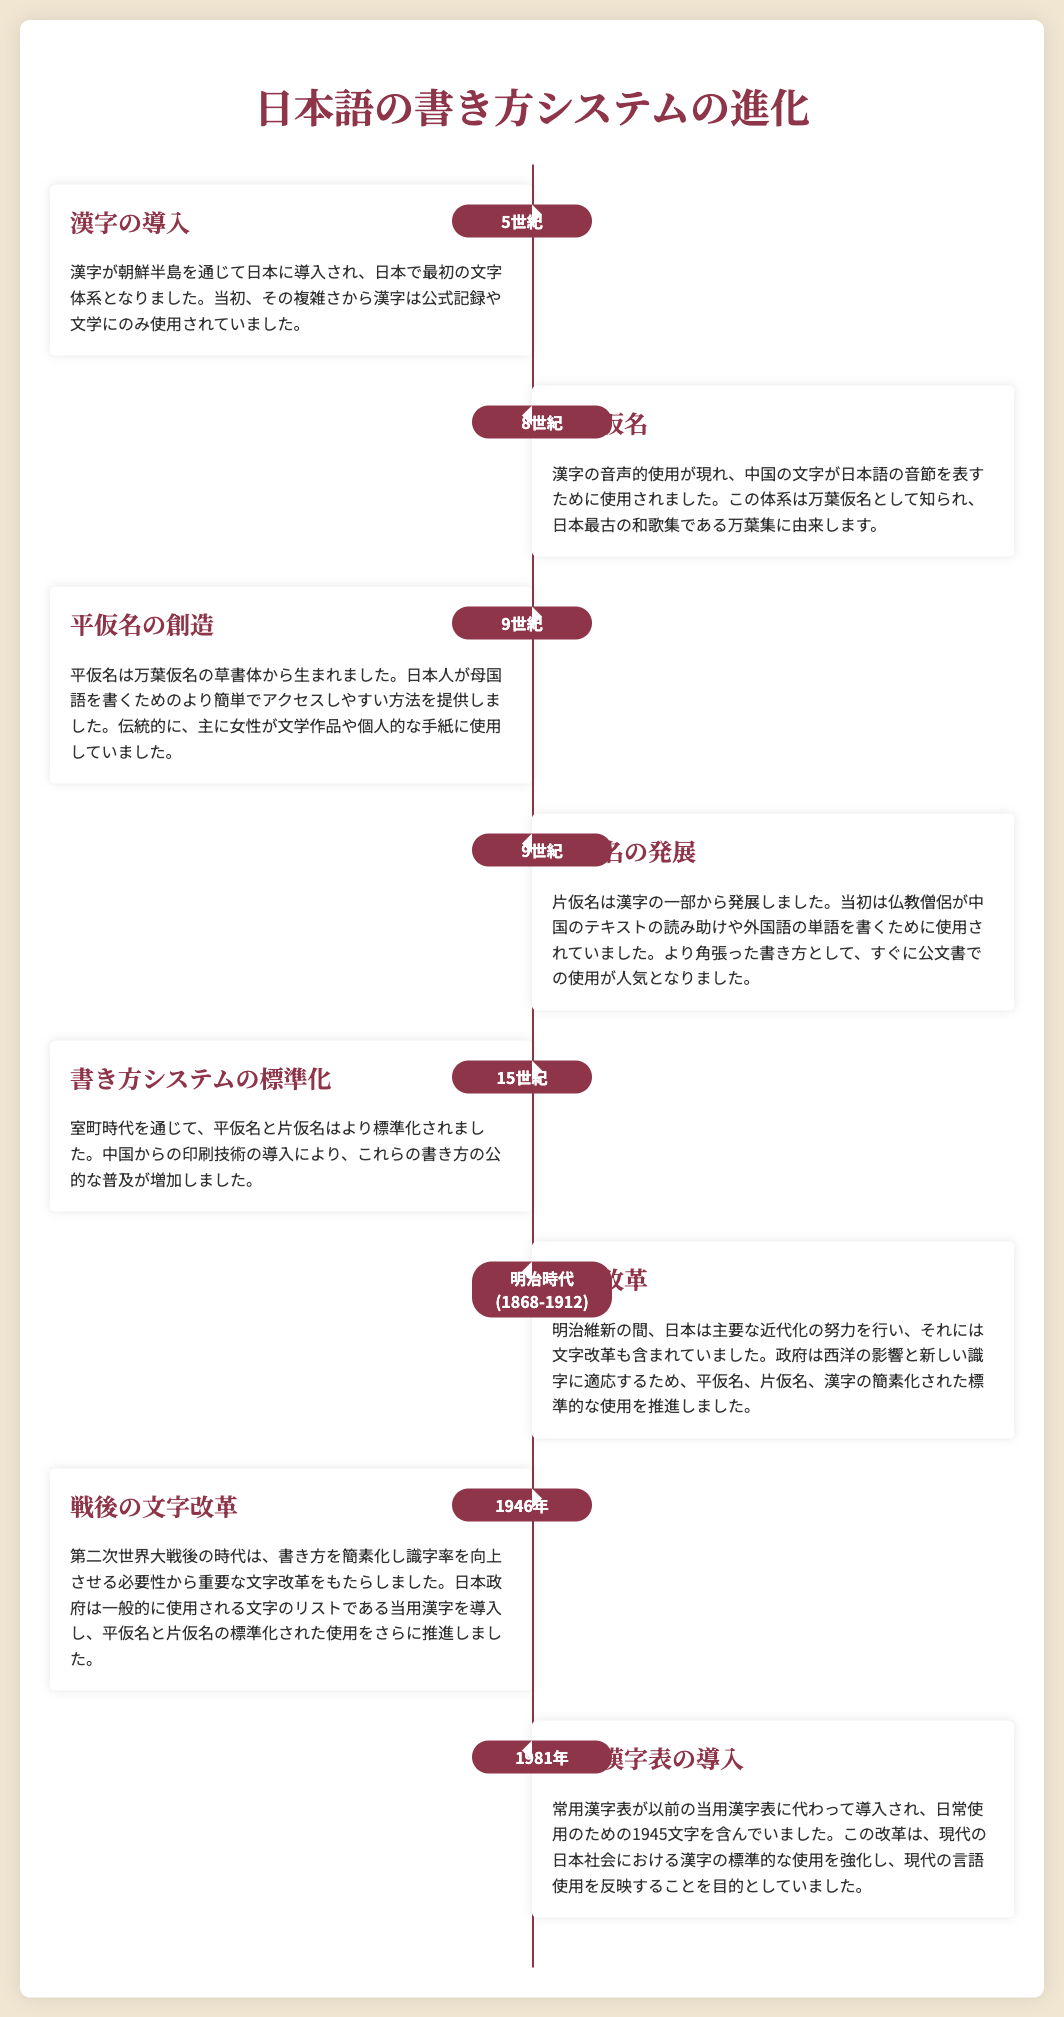what year was kanji introduced? The document states that kanji was introduced in the 5th century.
Answer: 5世紀 what is the name of the first writing system in Japan? The first writing system introduced to Japan was kanji.
Answer: 漢字 which writing system did women traditionally use for literature? The document mentions that hiragana was primarily used by women for literary works.
Answer: 平仮名 what significant reform happened during the Meiji period? During the Meiji period, language reform efforts were made to standardize the use of hiragana, katakana, and kanji.
Answer: 言語改革 what was the purpose of the commonly used kanji list introduced in 1946? The purpose of the list was to simplify writing and improve literacy rates.
Answer: 書き方を簡素化し識字率を向上させる what century saw the creation of hiragana? The document indicates that hiragana was created in the 9th century.
Answer: 9世紀 how many characters are included in the jōyō kanji table established in 1981? The document states that the jōyō kanji table includes 1945 characters for everyday use.
Answer: 1945文字 what writing system developed from part of kanji? The document clarifies that katakana developed from parts of kanji.
Answer: 片仮名 what technological influence contributed to the standardization of writing systems in the 15th century? The document mentions that the introduction of printing technology from China aided in the standardization.
Answer: 印刷技術 